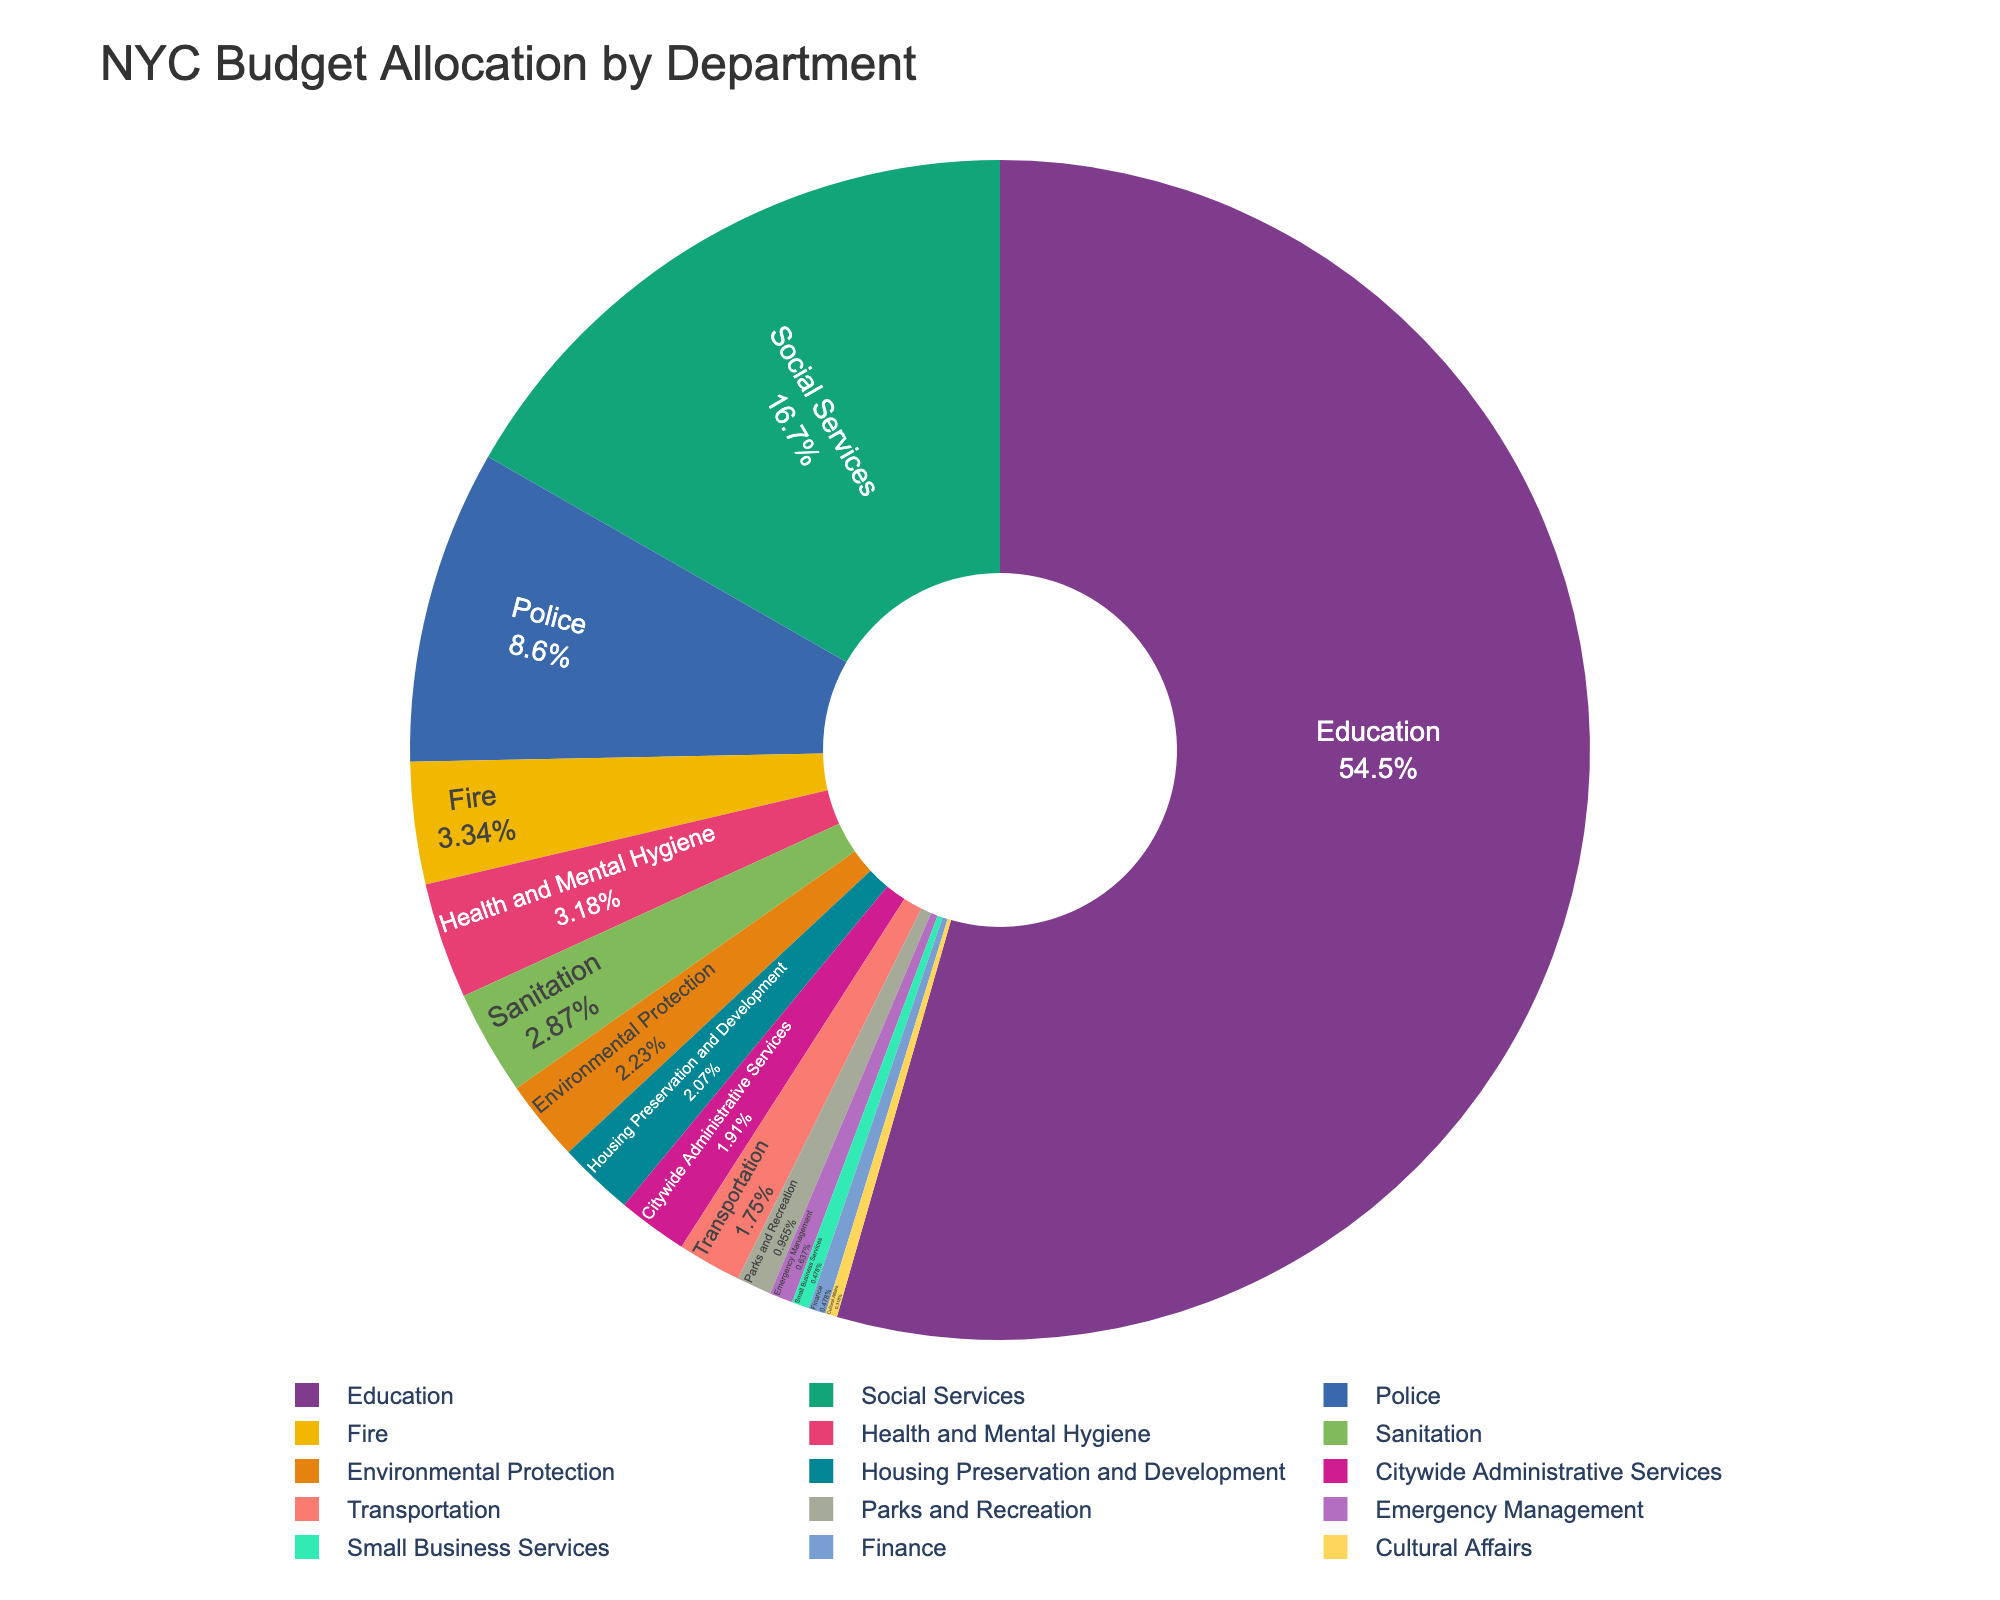Which department receives the highest budget allocation? The Education department receives the highest budget allocation as it has the largest section in the pie chart.
Answer: Education What percentage of the budget is allocated to Social Services? By referring to the pie chart, Social Services can be found, and we can see the percentage written on its section.
Answer: 10.5% What is the total budget allocated to Police and Fire departments combined? The budget for the Police department is $5.4 billion and for the Fire department is $2.1 billion. Adding them gives $5.4 + $2.1 = $7.5 billion.
Answer: $7.5 billion Which two departments have the smallest budget allocations? The smallest sections in the pie chart represent Cultural Affairs and Small Business Services.
Answer: Cultural Affairs, Small Business Services How does the budget for Environmental Protection compare to that for Housing Preservation and Development? The pie chart shows Environmental Protection has a slightly larger section than Housing Preservation and Development. Hence, Environmental Protection has a higher budget.
Answer: Environmental Protection What is the average budget allocation for Health and Mental Hygiene, Transportation, and Parks and Recreation? Sum the budgets: Health and Mental Hygiene ($2.0B) + Transportation ($1.1B) + Parks and Recreation ($0.6B) = $3.7 billion. Divide by 3 to get the average: $3.7 billion / 3 ≈ $1.23 billion.
Answer: $1.23 billion What fraction of the total budget is allocated to the Education department? The Education department's allocation is $34.2 billion, and the total budget can be summed from all sections. Total budget ≈ $62.5 billion. Fraction is $34.2 billion / $62.5 billion ≈ 0.547.
Answer: 0.547 Is the budget allocation for Social Services more than double that for Police? Social Services allocation is $10.5 billion, and Police allocation is $5.4 billion. Since $10.5 billion > 2 * $5.4 billion ($10.8 billion), Social Services is not more than double the Police budget.
Answer: No 